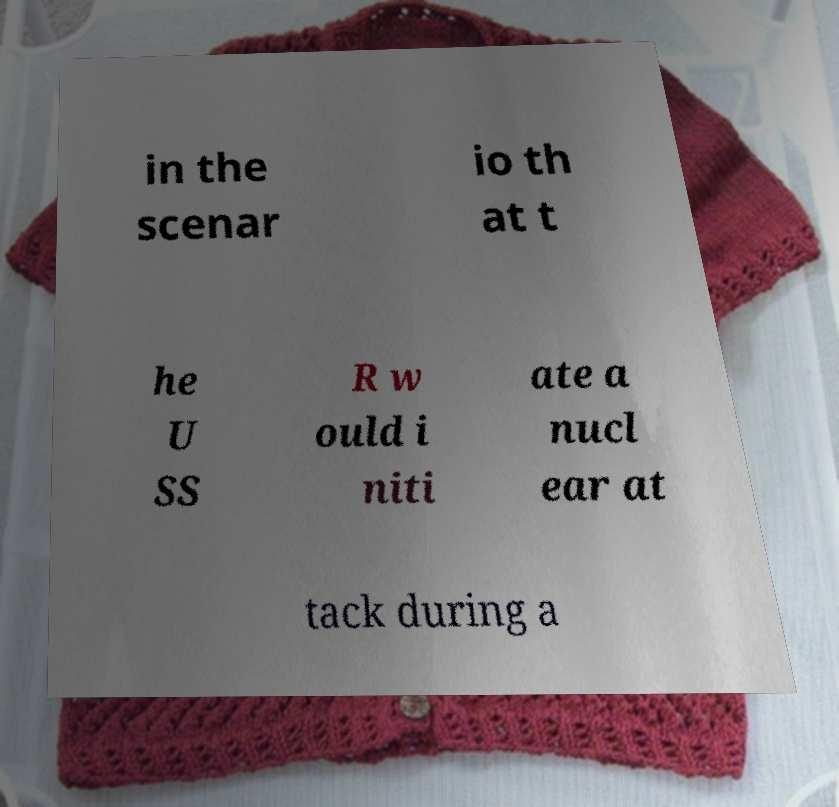Can you read and provide the text displayed in the image?This photo seems to have some interesting text. Can you extract and type it out for me? in the scenar io th at t he U SS R w ould i niti ate a nucl ear at tack during a 